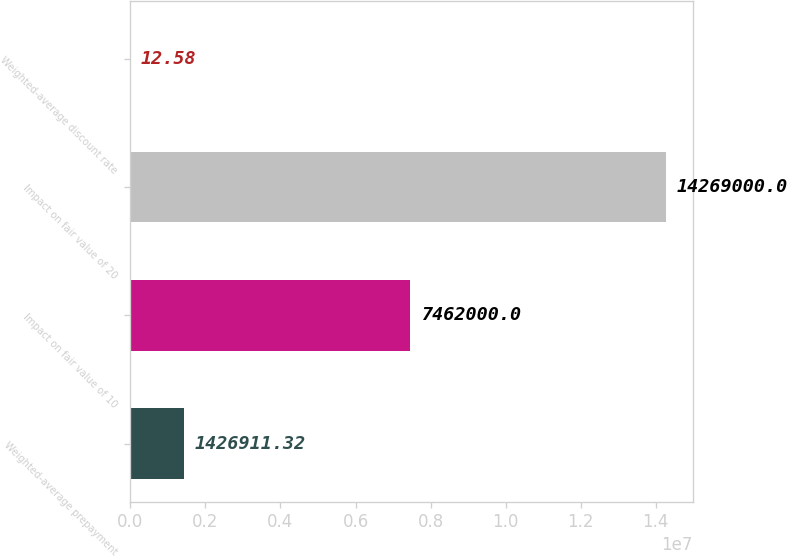<chart> <loc_0><loc_0><loc_500><loc_500><bar_chart><fcel>Weighted-average prepayment<fcel>Impact on fair value of 10<fcel>Impact on fair value of 20<fcel>Weighted-average discount rate<nl><fcel>1.42691e+06<fcel>7.462e+06<fcel>1.4269e+07<fcel>12.58<nl></chart> 